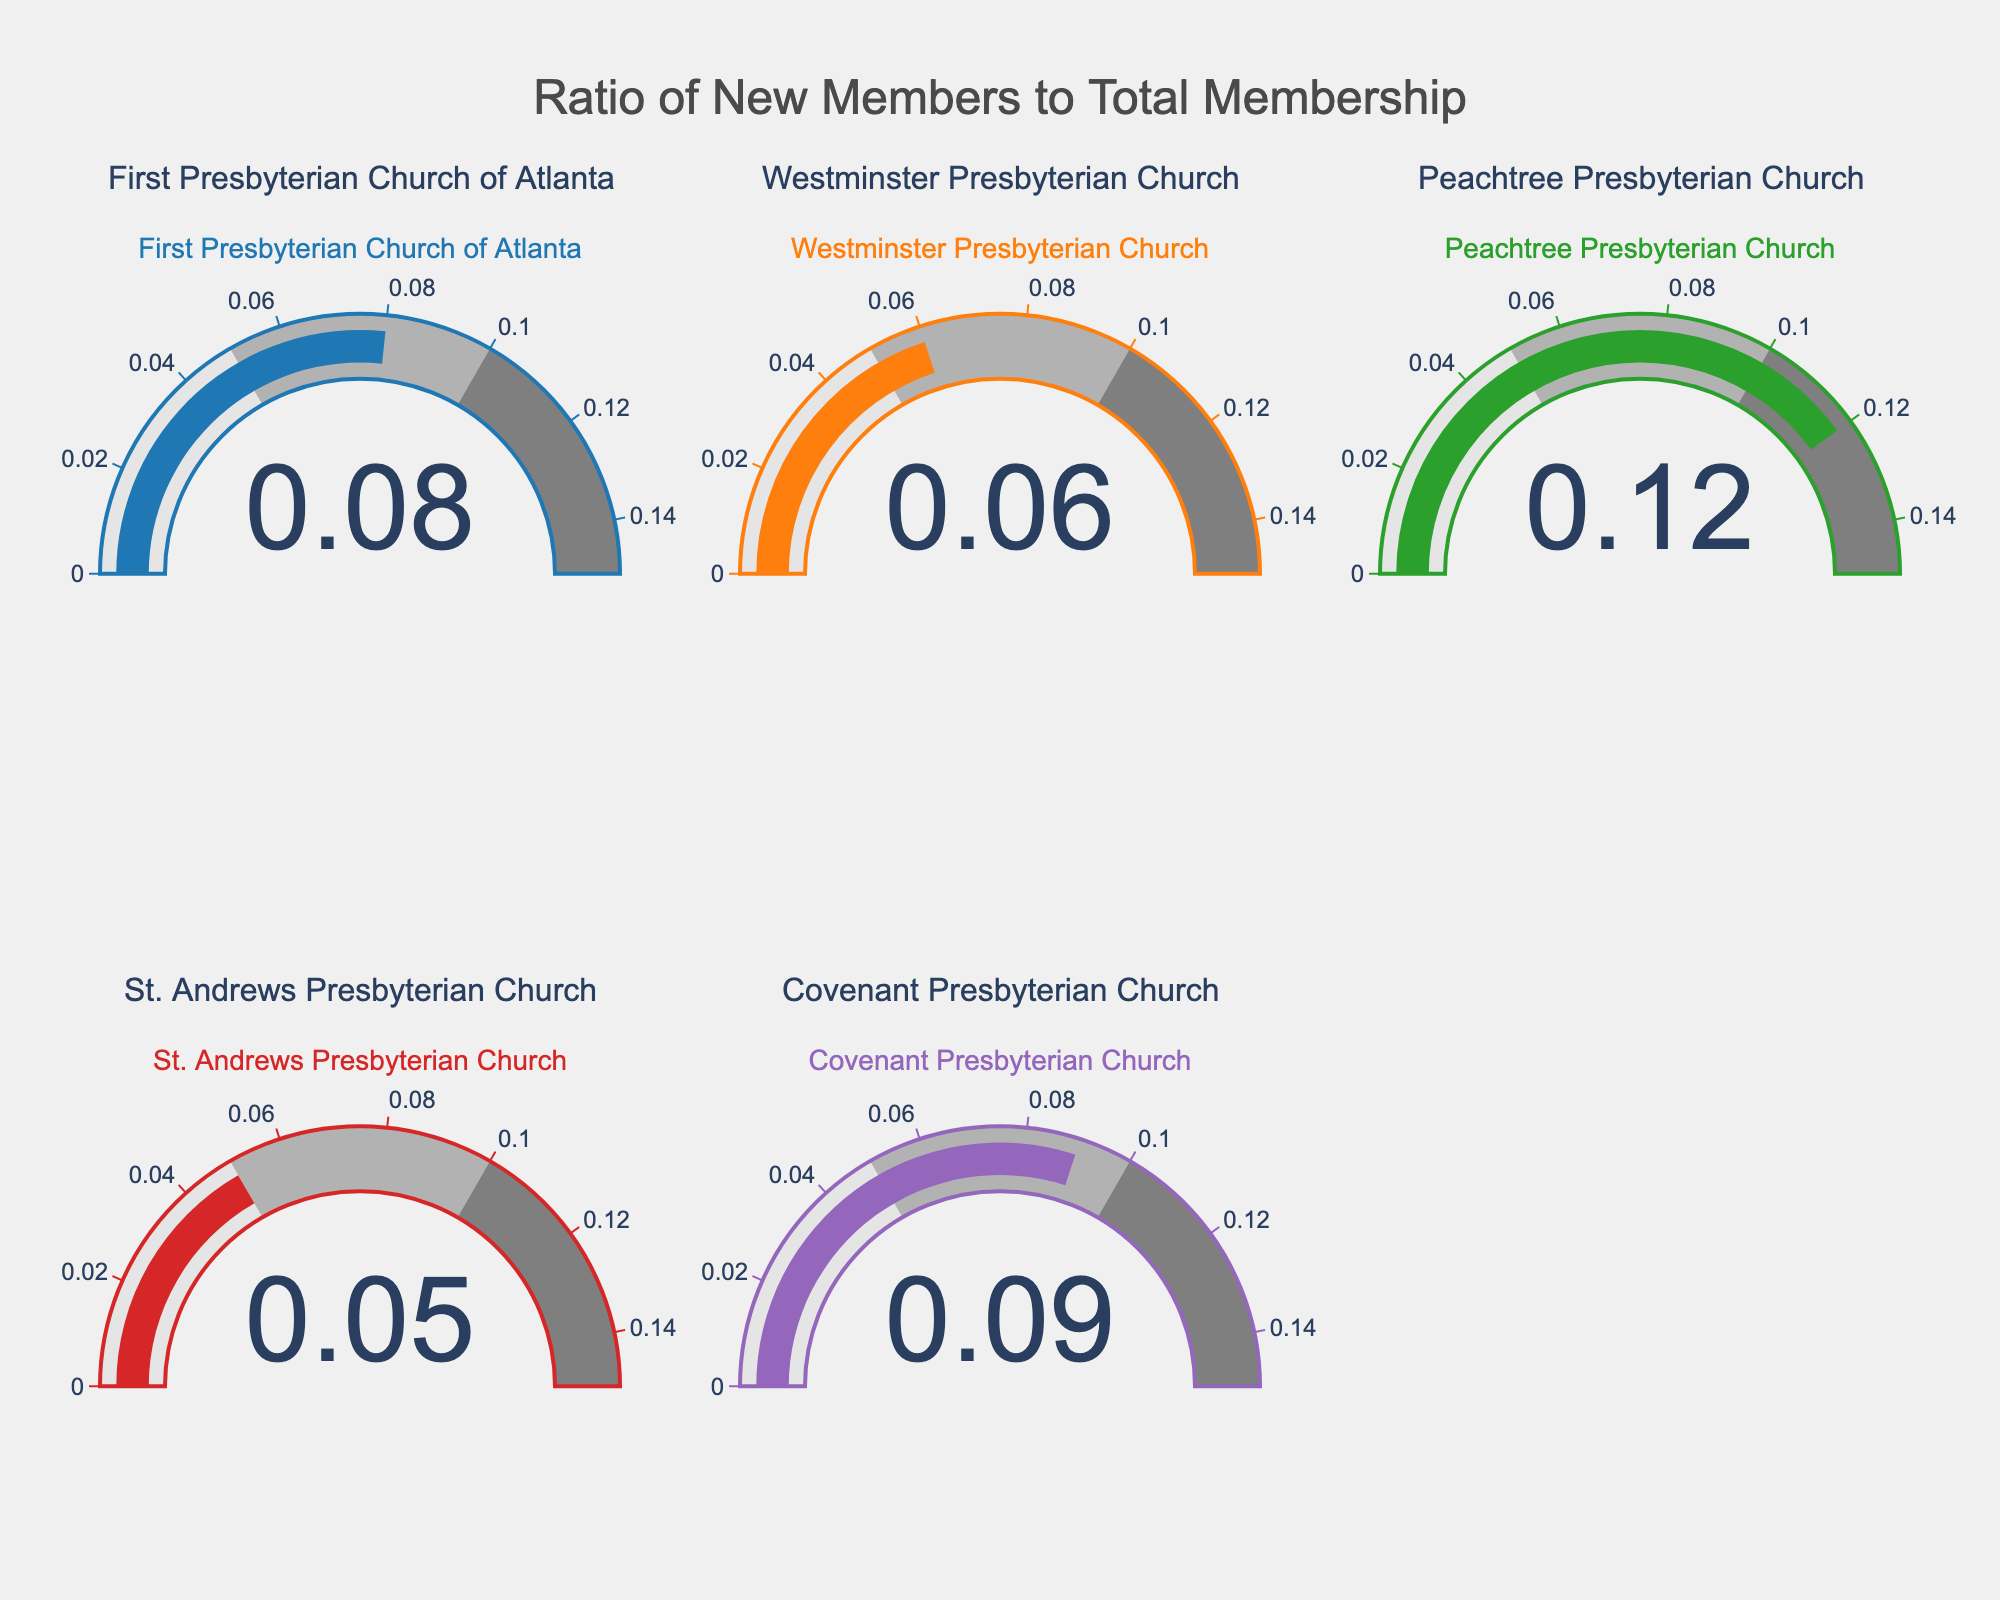What is the ratio of new members to total membership for Peachtree Presbyterian Church? Look at the gauge chart labeled "Peachtree Presbyterian Church" and read the number displayed, which is the ratio of new members to total membership.
Answer: 0.12 Which church has the lowest ratio of new members to total membership? Compare the ratios displayed on all the gauge charts. The lowest value is 0.05, which corresponds to St. Andrews Presbyterian Church.
Answer: St. Andrews Presbyterian Church How many churches have a ratio of new members to total membership greater than 0.08? Identify the churches with ratios greater than 0.08: First Presbyterian Church of Atlanta, Peachtree Presbyterian Church, and Covenant Presbyterian Church. Count them.
Answer: 3 Is the ratio of new members to total membership for Westminster Presbyterian Church greater than that for St. Andrews Presbyterian Church? Compare the ratio values for Westminster Presbyterian Church (0.06) and St. Andrews Presbyterian Church (0.05).
Answer: Yes What's the difference in the ratios of new members between Covenant Presbyterian Church and Westminster Presbyterian Church? Subtract the ratio of Westminster Presbyterian Church (0.06) from that of Covenant Presbyterian Church (0.09). The calculation is 0.09 - 0.06.
Answer: 0.03 What's the average ratio of new members to total membership for all churches? Add all the ratios and divide by the number of churches: (0.08 + 0.06 + 0.12 + 0.05 + 0.09) / 5 = 0.08
Answer: 0.08 Which church has the highest ratio of new members to total membership? Compare the ratios across all gauge charts and find the highest value, which is 0.12 for Peachtree Presbyterian Church.
Answer: Peachtree Presbyterian Church Is the ratio of new members for Covenant Presbyterian Church within the range [0.05, 0.1]? Verify if 0.09 falls within the range of 0.05 to 0.1.
Answer: Yes What is the sum of ratios for St. Andrews Presbyterian Church and First Presbyterian Church of Atlanta? Add the ratios of St. Andrews Presbyterian Church (0.05) and First Presbyterian Church of Atlanta (0.08). The calculation is 0.05 + 0.08.
Answer: 0.13 